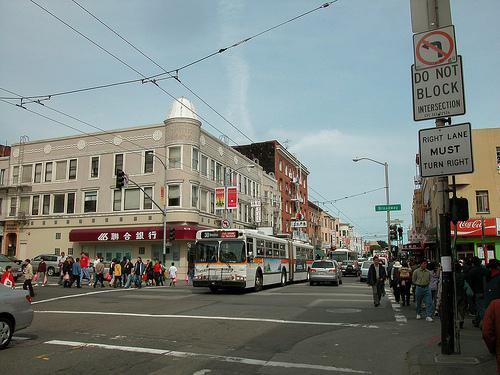Question: where was this taken?
Choices:
A. A park.
B. The bedroom.
C. Downtown.
D. The kitchen.
Answer with the letter. Answer: C Question: what are the people doing?
Choices:
A. Eating.
B. Sleeping.
C. Crossing the street.
D. Dancing.
Answer with the letter. Answer: C Question: what kinds of transportation are shown?
Choices:
A. Trains.
B. Cars and buses.
C. Airplanes.
D. Motorcycles and bicycles.
Answer with the letter. Answer: B Question: what is above the people and traffic?
Choices:
A. Clouds.
B. Power lines.
C. Lights.
D. Planes.
Answer with the letter. Answer: B 